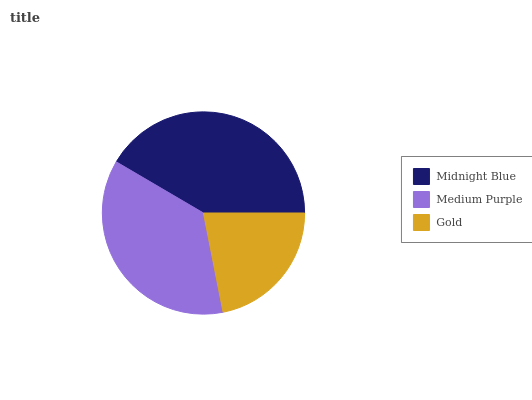Is Gold the minimum?
Answer yes or no. Yes. Is Midnight Blue the maximum?
Answer yes or no. Yes. Is Medium Purple the minimum?
Answer yes or no. No. Is Medium Purple the maximum?
Answer yes or no. No. Is Midnight Blue greater than Medium Purple?
Answer yes or no. Yes. Is Medium Purple less than Midnight Blue?
Answer yes or no. Yes. Is Medium Purple greater than Midnight Blue?
Answer yes or no. No. Is Midnight Blue less than Medium Purple?
Answer yes or no. No. Is Medium Purple the high median?
Answer yes or no. Yes. Is Medium Purple the low median?
Answer yes or no. Yes. Is Midnight Blue the high median?
Answer yes or no. No. Is Midnight Blue the low median?
Answer yes or no. No. 